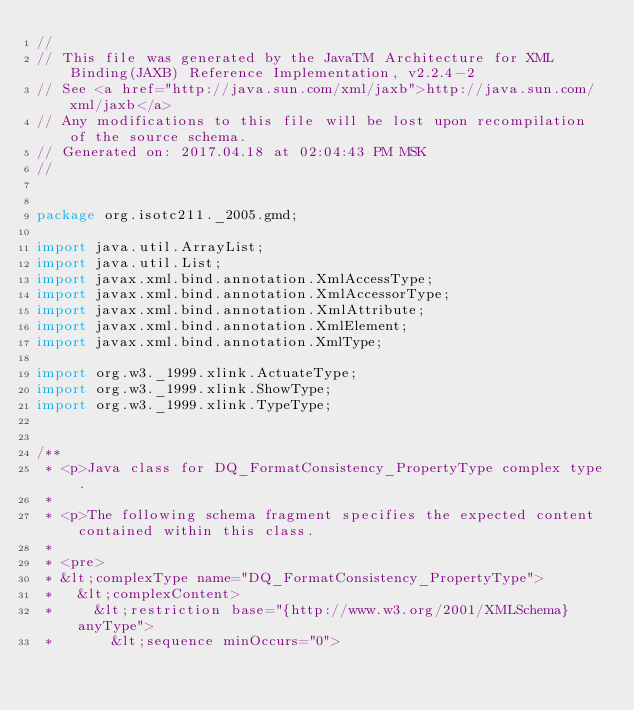Convert code to text. <code><loc_0><loc_0><loc_500><loc_500><_Java_>//
// This file was generated by the JavaTM Architecture for XML Binding(JAXB) Reference Implementation, v2.2.4-2 
// See <a href="http://java.sun.com/xml/jaxb">http://java.sun.com/xml/jaxb</a> 
// Any modifications to this file will be lost upon recompilation of the source schema. 
// Generated on: 2017.04.18 at 02:04:43 PM MSK 
//


package org.isotc211._2005.gmd;

import java.util.ArrayList;
import java.util.List;
import javax.xml.bind.annotation.XmlAccessType;
import javax.xml.bind.annotation.XmlAccessorType;
import javax.xml.bind.annotation.XmlAttribute;
import javax.xml.bind.annotation.XmlElement;
import javax.xml.bind.annotation.XmlType;

import org.w3._1999.xlink.ActuateType;
import org.w3._1999.xlink.ShowType;
import org.w3._1999.xlink.TypeType;


/**
 * <p>Java class for DQ_FormatConsistency_PropertyType complex type.
 * 
 * <p>The following schema fragment specifies the expected content contained within this class.
 * 
 * <pre>
 * &lt;complexType name="DQ_FormatConsistency_PropertyType">
 *   &lt;complexContent>
 *     &lt;restriction base="{http://www.w3.org/2001/XMLSchema}anyType">
 *       &lt;sequence minOccurs="0"></code> 